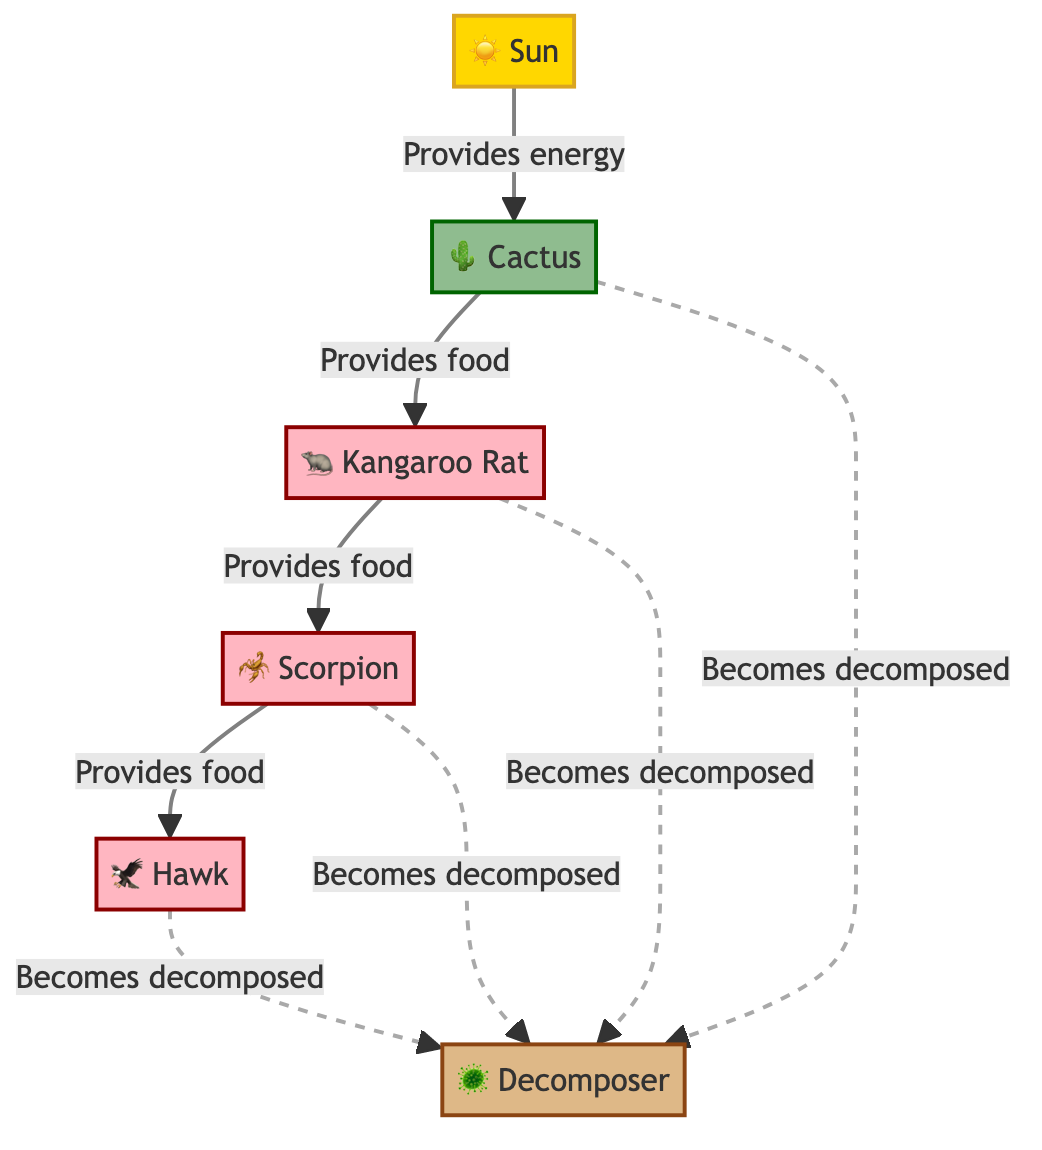What is the primary energy source in the food chain? The diagram shows the Sun as the starting point, indicated by the arrow pointing from the Sun to the Cactus, which provides energy for the entire food chain.
Answer: Sun Which organism is a producer in this food chain? The Cactus is categorized as a producer in the diagram, as it is colored and labeled accordingly, providing food for the first consumer, the Kangaroo Rat.
Answer: Cactus How many consumers are present in the food chain? The diagram lists three organisms that are consumers: the Kangaroo Rat, Scorpion, and Hawk, leading to a total of three consumers.
Answer: 3 What type of organism does the Scorpion provide food for? The Scorpion feeds the Hawk, as indicated by the directional arrow from Scorpion to Hawk, showing the flow of energy in the food chain.
Answer: Hawk Which organism becomes decomposed by the Decomposer? The Decomposer is connected to the Hawk, Scorpion, Kangaroo Rat, and Cactus, indicating that all these organisms are eventually decomposed by it in the cycle.
Answer: All listed Which two organisms directly connect in terms of food provision? The direct flow of food provision can be traced from the Cactus to the Kangaroo Rat, demonstrating how energy is passed from the producer to the primary consumer.
Answer: Cactus to Kangaroo Rat What color represents decomposers in the diagram? The Decomposer is colored in a specific shade identified as brown, distinct from the green of producers and pink of consumers, making it easily identifiable as decomposer.
Answer: Brown What relationship does the Sun have with the Cactus? The Sun provides energy to the Cactus, as shown by the arrow pointing from the Sun to the Cactus, indicating the beginning of the food chain.
Answer: Provides energy How do consumers affect the decomposer in the food chain? Consumers like the Hawk, Scorpion, and Kangaroo Rat all become decomposed after their life cycle ends, showing a flow of energy from living organisms to the Decomposer for nutrient cycling.
Answer: Become decomposed 